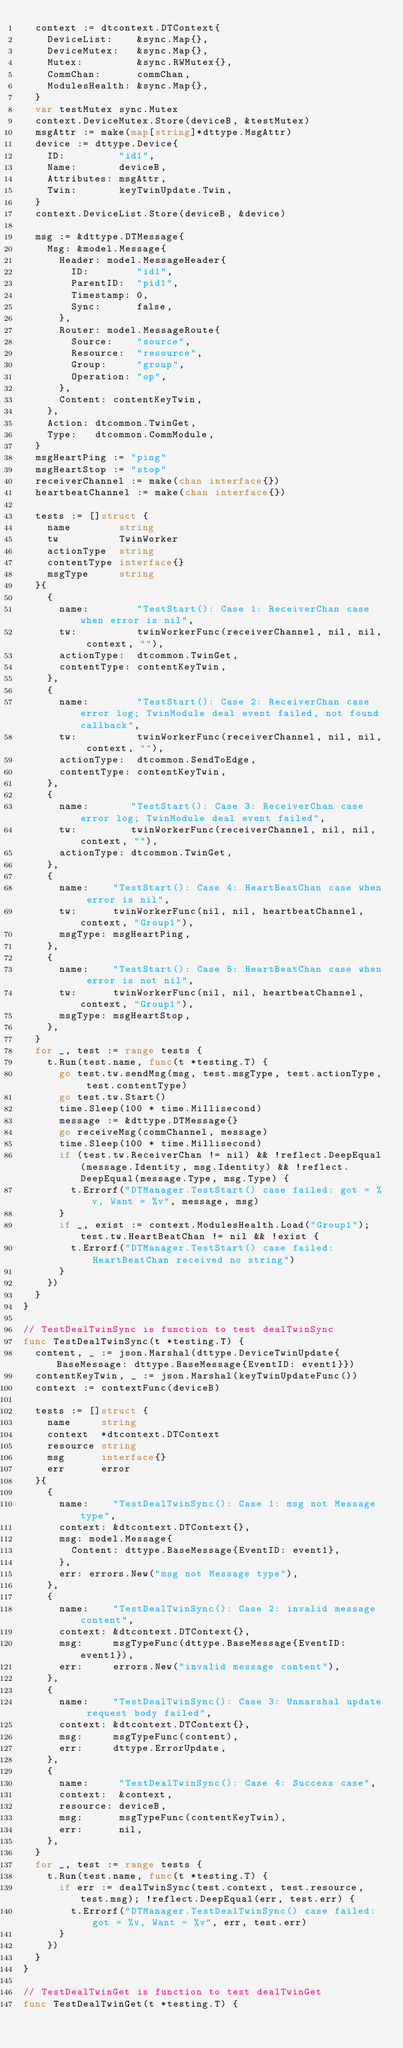Convert code to text. <code><loc_0><loc_0><loc_500><loc_500><_Go_>	context := dtcontext.DTContext{
		DeviceList:    &sync.Map{},
		DeviceMutex:   &sync.Map{},
		Mutex:         &sync.RWMutex{},
		CommChan:      commChan,
		ModulesHealth: &sync.Map{},
	}
	var testMutex sync.Mutex
	context.DeviceMutex.Store(deviceB, &testMutex)
	msgAttr := make(map[string]*dttype.MsgAttr)
	device := dttype.Device{
		ID:         "id1",
		Name:       deviceB,
		Attributes: msgAttr,
		Twin:       keyTwinUpdate.Twin,
	}
	context.DeviceList.Store(deviceB, &device)

	msg := &dttype.DTMessage{
		Msg: &model.Message{
			Header: model.MessageHeader{
				ID:        "id1",
				ParentID:  "pid1",
				Timestamp: 0,
				Sync:      false,
			},
			Router: model.MessageRoute{
				Source:    "source",
				Resource:  "resource",
				Group:     "group",
				Operation: "op",
			},
			Content: contentKeyTwin,
		},
		Action: dtcommon.TwinGet,
		Type:   dtcommon.CommModule,
	}
	msgHeartPing := "ping"
	msgHeartStop := "stop"
	receiverChannel := make(chan interface{})
	heartbeatChannel := make(chan interface{})

	tests := []struct {
		name        string
		tw          TwinWorker
		actionType  string
		contentType interface{}
		msgType     string
	}{
		{
			name:        "TestStart(): Case 1: ReceiverChan case when error is nil",
			tw:          twinWorkerFunc(receiverChannel, nil, nil, context, ""),
			actionType:  dtcommon.TwinGet,
			contentType: contentKeyTwin,
		},
		{
			name:        "TestStart(): Case 2: ReceiverChan case error log; TwinModule deal event failed, not found callback",
			tw:          twinWorkerFunc(receiverChannel, nil, nil, context, ""),
			actionType:  dtcommon.SendToEdge,
			contentType: contentKeyTwin,
		},
		{
			name:       "TestStart(): Case 3: ReceiverChan case error log; TwinModule deal event failed",
			tw:         twinWorkerFunc(receiverChannel, nil, nil, context, ""),
			actionType: dtcommon.TwinGet,
		},
		{
			name:    "TestStart(): Case 4: HeartBeatChan case when error is nil",
			tw:      twinWorkerFunc(nil, nil, heartbeatChannel, context, "Group1"),
			msgType: msgHeartPing,
		},
		{
			name:    "TestStart(): Case 5: HeartBeatChan case when error is not nil",
			tw:      twinWorkerFunc(nil, nil, heartbeatChannel, context, "Group1"),
			msgType: msgHeartStop,
		},
	}
	for _, test := range tests {
		t.Run(test.name, func(t *testing.T) {
			go test.tw.sendMsg(msg, test.msgType, test.actionType, test.contentType)
			go test.tw.Start()
			time.Sleep(100 * time.Millisecond)
			message := &dttype.DTMessage{}
			go receiveMsg(commChannel, message)
			time.Sleep(100 * time.Millisecond)
			if (test.tw.ReceiverChan != nil) && !reflect.DeepEqual(message.Identity, msg.Identity) && !reflect.DeepEqual(message.Type, msg.Type) {
				t.Errorf("DTManager.TestStart() case failed: got = %v, Want = %v", message, msg)
			}
			if _, exist := context.ModulesHealth.Load("Group1"); test.tw.HeartBeatChan != nil && !exist {
				t.Errorf("DTManager.TestStart() case failed: HeartBeatChan received no string")
			}
		})
	}
}

// TestDealTwinSync is function to test dealTwinSync
func TestDealTwinSync(t *testing.T) {
	content, _ := json.Marshal(dttype.DeviceTwinUpdate{BaseMessage: dttype.BaseMessage{EventID: event1}})
	contentKeyTwin, _ := json.Marshal(keyTwinUpdateFunc())
	context := contextFunc(deviceB)

	tests := []struct {
		name     string
		context  *dtcontext.DTContext
		resource string
		msg      interface{}
		err      error
	}{
		{
			name:    "TestDealTwinSync(): Case 1: msg not Message type",
			context: &dtcontext.DTContext{},
			msg: model.Message{
				Content: dttype.BaseMessage{EventID: event1},
			},
			err: errors.New("msg not Message type"),
		},
		{
			name:    "TestDealTwinSync(): Case 2: invalid message content",
			context: &dtcontext.DTContext{},
			msg:     msgTypeFunc(dttype.BaseMessage{EventID: event1}),
			err:     errors.New("invalid message content"),
		},
		{
			name:    "TestDealTwinSync(): Case 3: Unmarshal update request body failed",
			context: &dtcontext.DTContext{},
			msg:     msgTypeFunc(content),
			err:     dttype.ErrorUpdate,
		},
		{
			name:     "TestDealTwinSync(): Case 4: Success case",
			context:  &context,
			resource: deviceB,
			msg:      msgTypeFunc(contentKeyTwin),
			err:      nil,
		},
	}
	for _, test := range tests {
		t.Run(test.name, func(t *testing.T) {
			if err := dealTwinSync(test.context, test.resource, test.msg); !reflect.DeepEqual(err, test.err) {
				t.Errorf("DTManager.TestDealTwinSync() case failed: got = %v, Want = %v", err, test.err)
			}
		})
	}
}

// TestDealTwinGet is function to test dealTwinGet
func TestDealTwinGet(t *testing.T) {</code> 